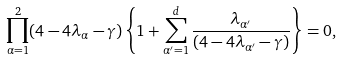<formula> <loc_0><loc_0><loc_500><loc_500>\prod _ { \alpha = 1 } ^ { 2 } ( 4 - 4 \lambda _ { \alpha } - \gamma ) \left \{ 1 + \sum _ { \alpha ^ { \prime } = 1 } ^ { d } \frac { \lambda _ { \alpha ^ { \prime } } } { ( 4 - 4 \lambda _ { \alpha ^ { \prime } } - \gamma ) } \right \} = 0 ,</formula> 